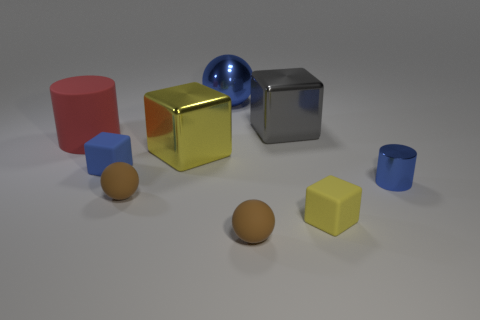The yellow metallic thing that is the same shape as the blue matte object is what size?
Offer a terse response. Large. What number of big spheres have the same material as the gray object?
Give a very brief answer. 1. What number of tiny metallic cylinders are the same color as the shiny ball?
Offer a very short reply. 1. How many objects are either large objects right of the blue rubber object or cubes that are behind the red object?
Offer a terse response. 3. Are there fewer big blue objects that are on the left side of the large yellow shiny cube than blue rubber cylinders?
Make the answer very short. No. Is there a yellow object of the same size as the blue cylinder?
Make the answer very short. Yes. The small metallic thing has what color?
Provide a short and direct response. Blue. Do the blue shiny cylinder and the red thing have the same size?
Offer a terse response. No. What number of objects are either matte spheres or blue rubber blocks?
Keep it short and to the point. 3. Is the number of metallic balls that are in front of the tiny yellow matte object the same as the number of large brown cubes?
Keep it short and to the point. Yes. 